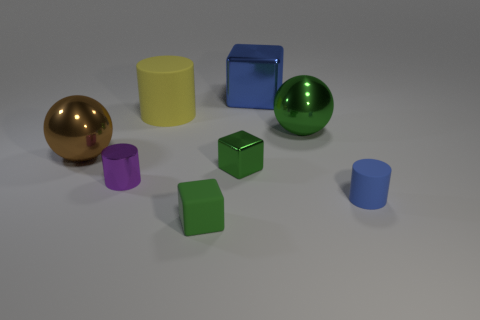Add 1 small blue cylinders. How many objects exist? 9 Subtract all cylinders. How many objects are left? 5 Add 8 blue objects. How many blue objects are left? 10 Add 6 red rubber spheres. How many red rubber spheres exist? 6 Subtract 0 brown cylinders. How many objects are left? 8 Subtract all big rubber cylinders. Subtract all big green objects. How many objects are left? 6 